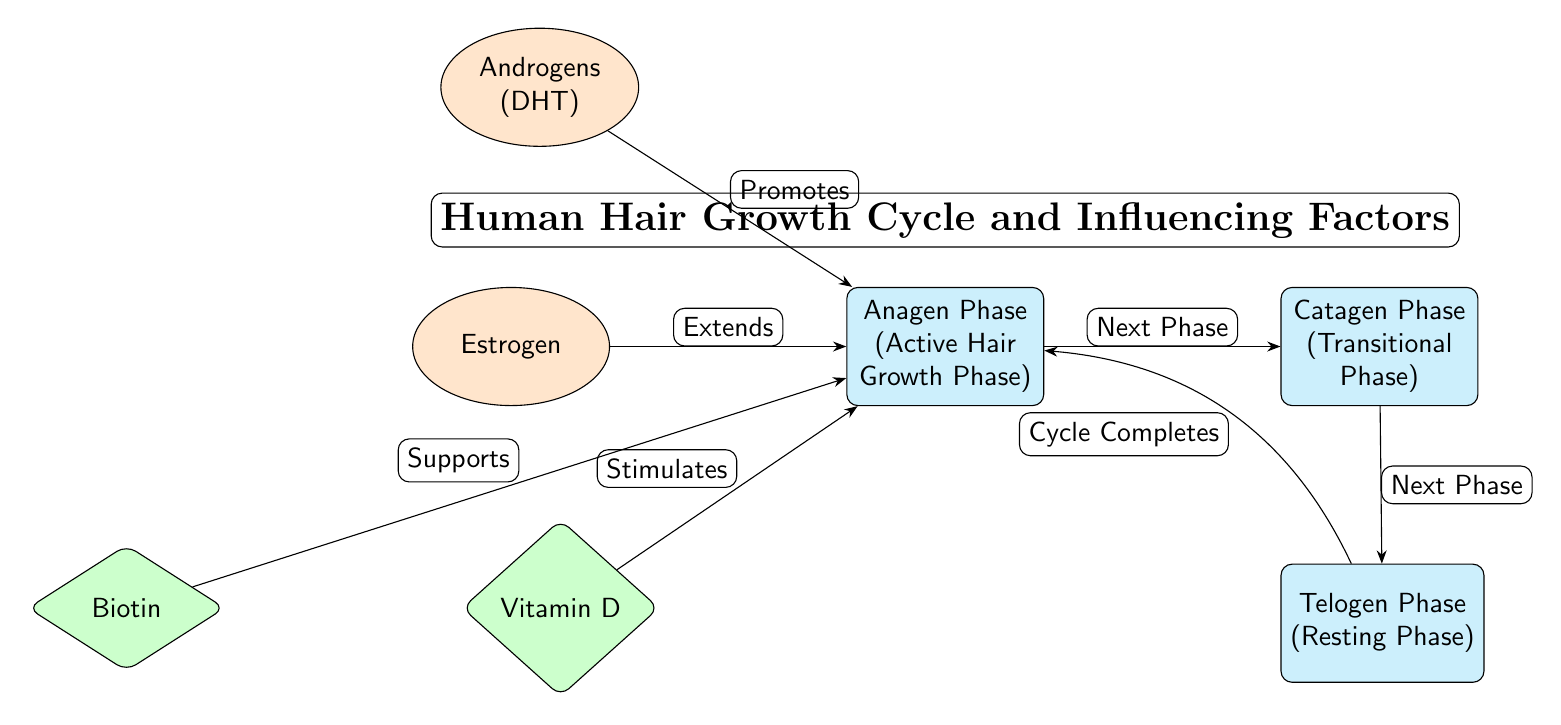What are the three phases of hair growth depicted in the diagram? The diagram shows three phases: Anagen Phase, Catagen Phase, and Telogen Phase. These are explicitly labeled in the nodes of the diagram.
Answer: Anagen Phase, Catagen Phase, Telogen Phase Which hormone promotes the Anagen Phase? The diagram indicates that Androgens (DHT) promotes the Anagen Phase, as shown by the directed arrow from the hormone node to the phase node.
Answer: Androgens (DHT) How many hormones are influencing the Anagen Phase? There are two hormones (Androgens and Estrogen) influencing the Anagen Phase as identified by the arrows pointing towards the Anagen Phase node.
Answer: 2 What nutrient is shown to support the Anagen Phase? The diagram illustrates that Biotin supports the Anagen Phase, indicated by the directed edge from the nutrient node to the phase node.
Answer: Biotin What happens after the Catagen Phase in the hair growth cycle? The diagram indicates that the next phase after Catagen Phase is the Telogen Phase, based on the directional arrow connecting the two phases.
Answer: Telogen Phase What action does Estrogen perform concerning the Anagen Phase? According to the diagram, Estrogen extends the Anagen Phase, evidenced by the label along the arrow pointing from Estrogen to the Anagen Phase node.
Answer: Extends Which phase of hair growth is described as the resting phase? The Telogen Phase is labeled as the resting phase directly in the node. This information is found in the label within the node representing this phase of the hair growth cycle.
Answer: Telogen Phase How does Vitamin D affect the Anagen Phase according to the diagram? The diagram states that Vitamin D stimulates the Anagen Phase, which is indicated by the arrow and label pointing from the nutrient node to the phase node.
Answer: Stimulates Which phase completes the cycle in the hair growth process? The diagram shows that the Telogen Phase completes the cycle as it points back to the Anagen Phase, which indicates that the hair growth cycle restarts after Telogen.
Answer: Anagen Phase 